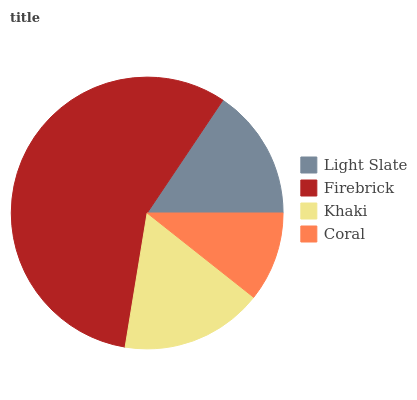Is Coral the minimum?
Answer yes or no. Yes. Is Firebrick the maximum?
Answer yes or no. Yes. Is Khaki the minimum?
Answer yes or no. No. Is Khaki the maximum?
Answer yes or no. No. Is Firebrick greater than Khaki?
Answer yes or no. Yes. Is Khaki less than Firebrick?
Answer yes or no. Yes. Is Khaki greater than Firebrick?
Answer yes or no. No. Is Firebrick less than Khaki?
Answer yes or no. No. Is Khaki the high median?
Answer yes or no. Yes. Is Light Slate the low median?
Answer yes or no. Yes. Is Coral the high median?
Answer yes or no. No. Is Khaki the low median?
Answer yes or no. No. 